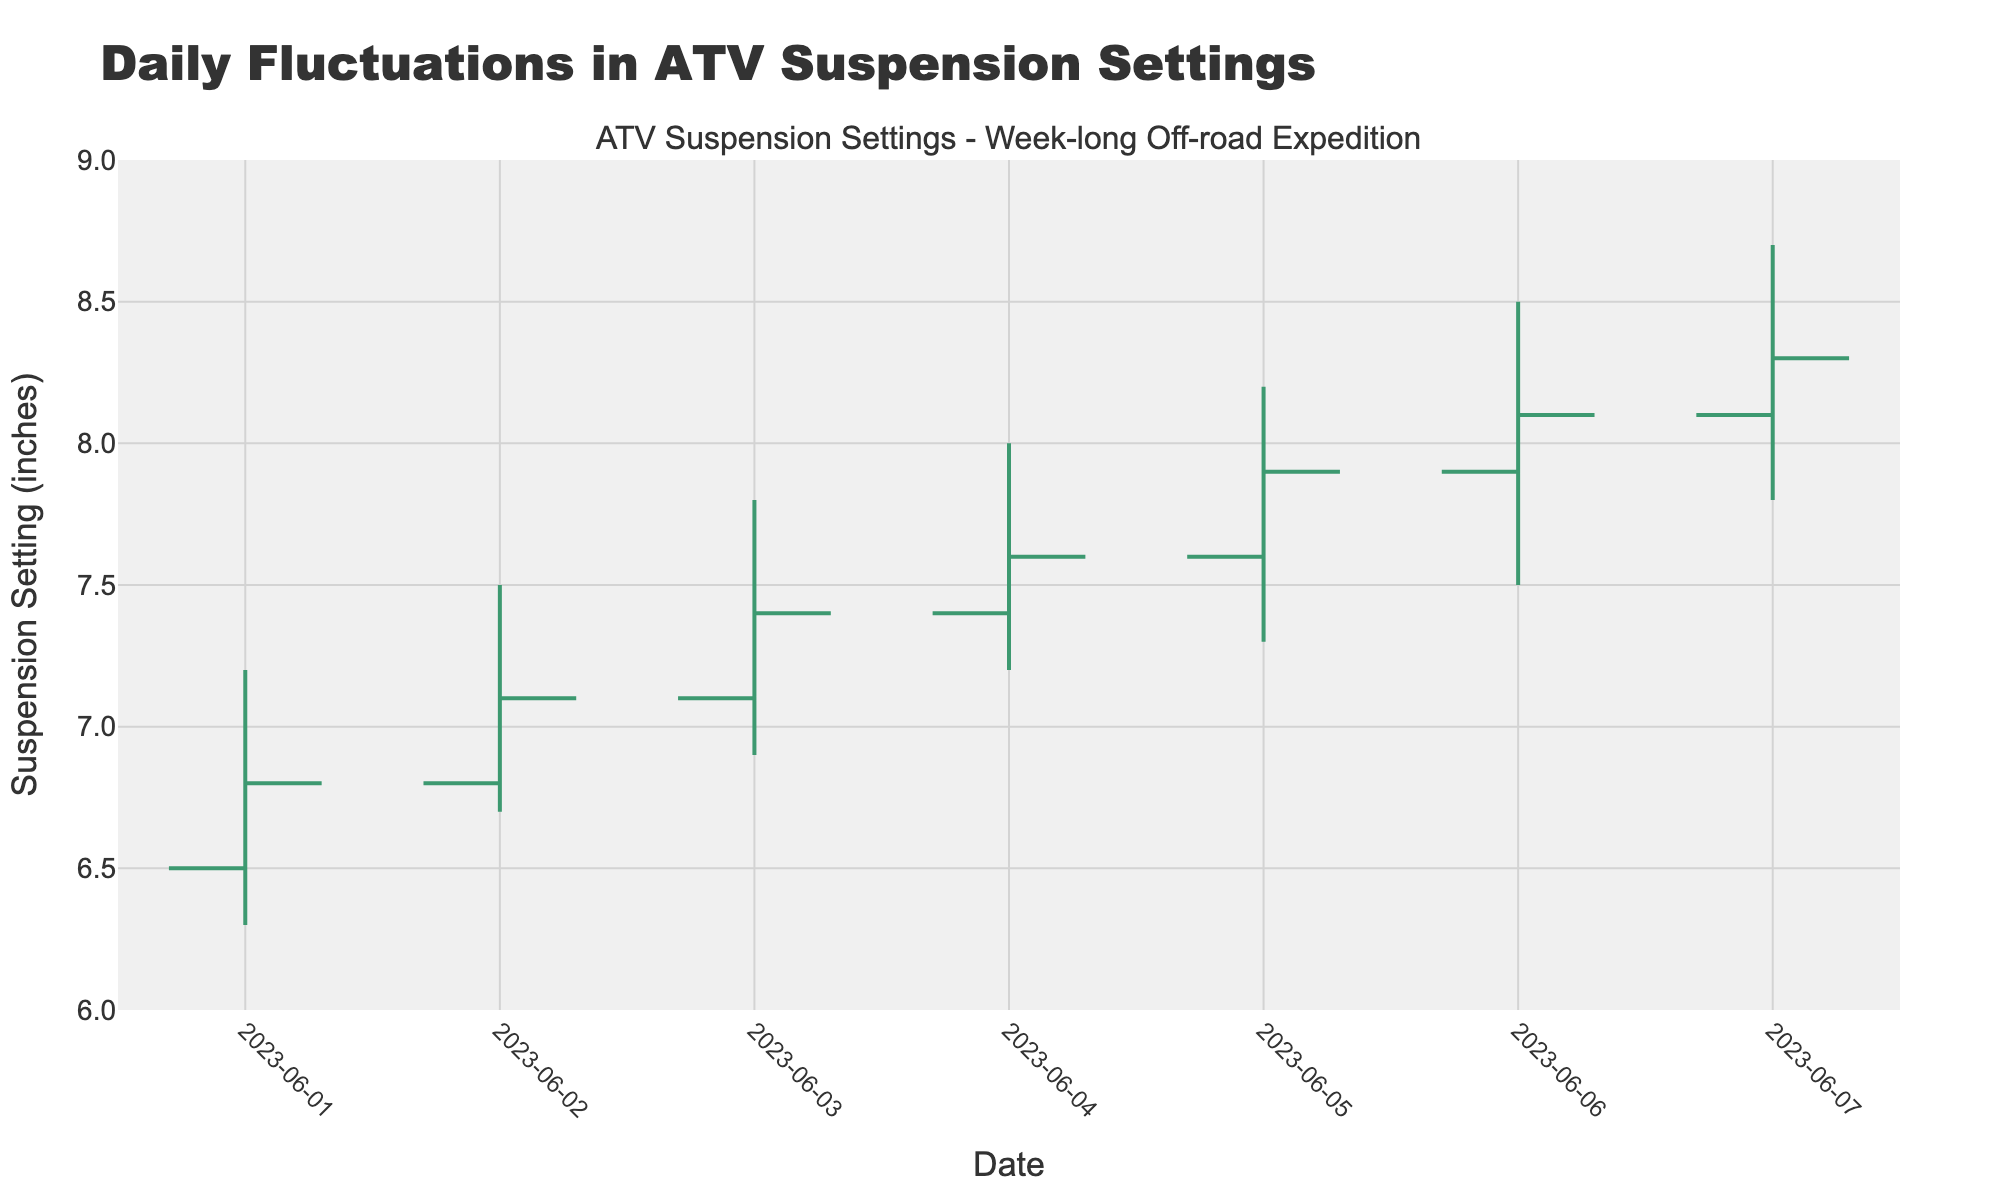What is the title of the figure? The title of the figure is displayed at the top and reads, "Daily Fluctuations in ATV Suspension Settings".
Answer: Daily Fluctuations in ATV Suspension Settings What is the highest suspension setting recorded during the week? The highest value on the y-axis ("High" column) represents the highest recorded value. It is 8.7 inches on 2023-06-07.
Answer: 8.7 inches What is the range of suspension settings on 2023-06-04? The range is calculated by subtracting the lowest value of the day ("Low") from the highest value of the day ("High"). For 2023-06-04, the range is 8.0 - 7.2 = 0.8 inches.
Answer: 0.8 inches Which day had the highest closing suspension setting? Look at the "Close" column and find the highest value, which is 8.3 inches on 2023-06-07.
Answer: 2023-06-07 Did suspension increase or decrease by the end of the day on 2023-06-01? Compare the "Open" and "Close" values for 2023-06-01. The "Open" was 6.5 and the "Close" was 6.8, indicating an increase.
Answer: Increase What is the average opening suspension setting over the week? Add the "Open" values for all seven days and divide by 7. (6.5 + 6.8 + 7.1 + 7.4 + 7.6 + 7.9 + 8.1) / 7 = 7.2 inches.
Answer: 7.2 inches Which day showed the largest single-day increase in suspension settings? Calculate the difference between "Close" and "Open" for each day and find the maximum. 2023-06-06 had the largest increase with a 0.2 inch rise (8.1 - 7.9).
Answer: 2023-06-06 How did the lowest suspension setting change from 2023-06-01 to 2023-06-07? Compare the "Low" values on both dates; it increased from 6.3 on 2023-06-01 to 7.8 on 2023-06-07, a change of 1.5 inches.
Answer: 1.5 inches increase Which dates showed a decrease in the suspension setting by the end of the day? Look for days where the "Close" value is lower than the "Open" value. There are no such days within the provided data as all "Close" values are equal to or higher than the "Open" values.
Answer: None What is the total range of suspension settings over the week? Subtract the lowest "Low" value for the week from the highest "High" value. The lowest "Low" is 6.3 inches (2023-06-01) and the highest "High" is 8.7 inches (2023-06-07); hence, the range is 8.7 - 6.3 = 2.4 inches.
Answer: 2.4 inches 